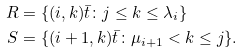Convert formula to latex. <formula><loc_0><loc_0><loc_500><loc_500>R & = \{ ( i , k ) \bar { t } \colon j \leq k \leq \lambda _ { i } \} \\ S & = \{ ( i + 1 , k ) \bar { t } \colon \mu _ { i + 1 } < k \leq j \} .</formula> 